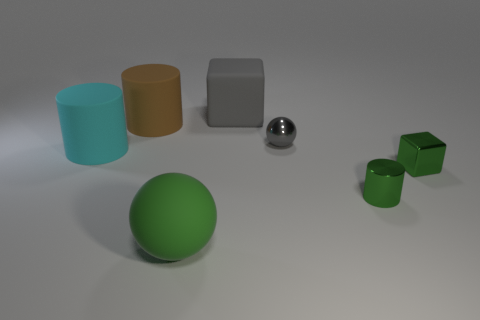Is there a sphere that has the same material as the large brown object?
Offer a terse response. Yes. What is the large cylinder that is right of the big cyan object made of?
Ensure brevity in your answer.  Rubber. There is a cube that is to the left of the small ball; is it the same color as the ball right of the green sphere?
Your answer should be compact. Yes. What is the color of the cube that is the same size as the gray metallic object?
Give a very brief answer. Green. How many other objects are the same shape as the large green object?
Provide a short and direct response. 1. There is a block that is on the right side of the metal cylinder; what size is it?
Keep it short and to the point. Small. What number of rubber cubes are to the right of the block that is in front of the gray metallic sphere?
Offer a very short reply. 0. What number of other objects are the same size as the gray metal sphere?
Your answer should be compact. 2. Does the metallic ball have the same color as the large cube?
Your response must be concise. Yes. There is a matte thing that is on the right side of the big green thing; is it the same shape as the gray metal object?
Ensure brevity in your answer.  No. 